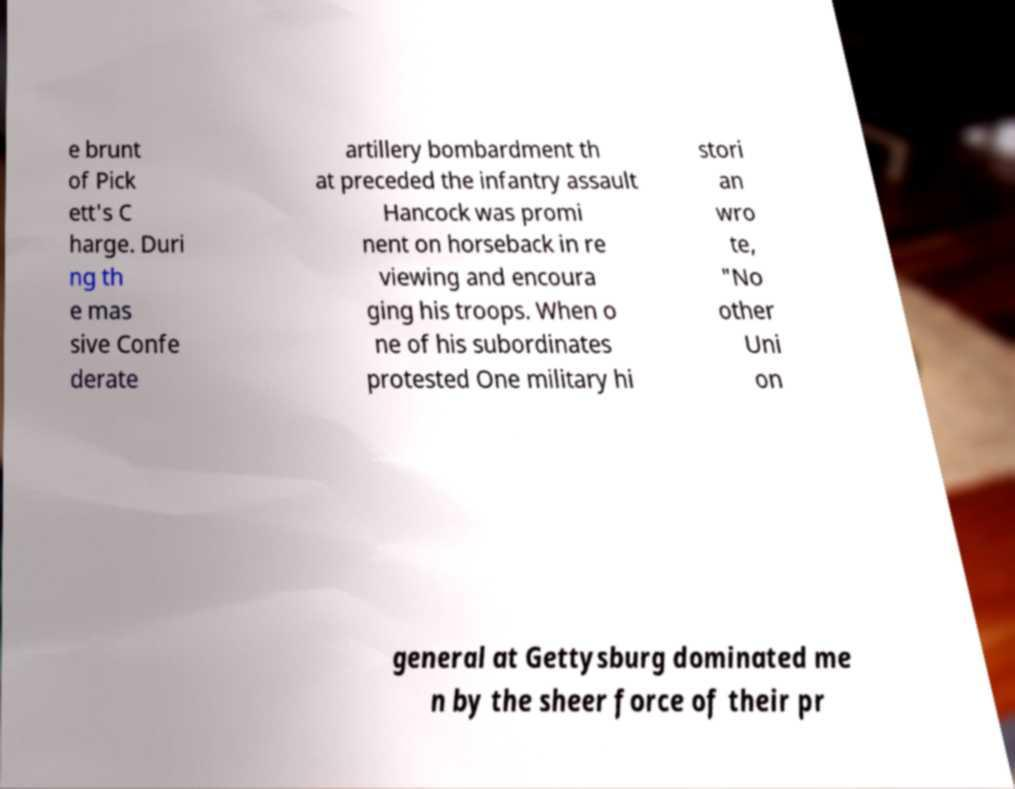There's text embedded in this image that I need extracted. Can you transcribe it verbatim? e brunt of Pick ett's C harge. Duri ng th e mas sive Confe derate artillery bombardment th at preceded the infantry assault Hancock was promi nent on horseback in re viewing and encoura ging his troops. When o ne of his subordinates protested One military hi stori an wro te, "No other Uni on general at Gettysburg dominated me n by the sheer force of their pr 